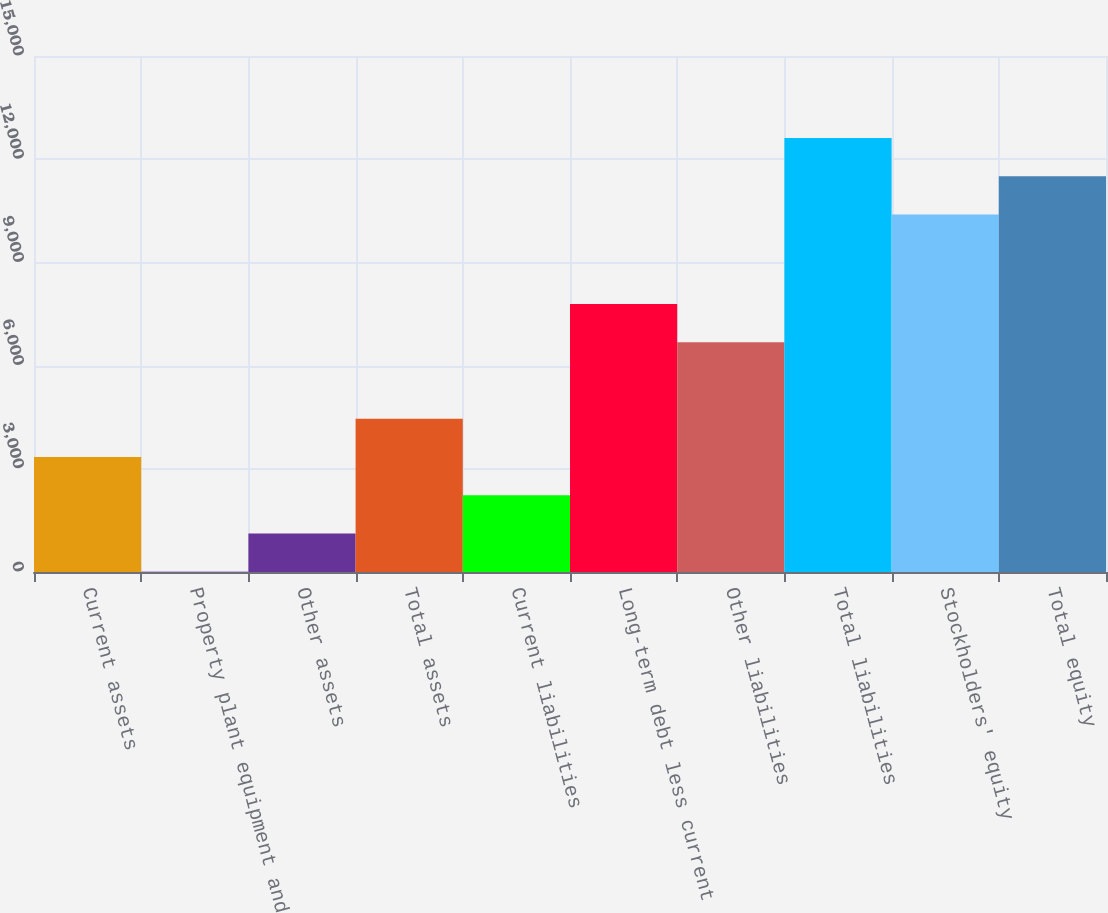Convert chart to OTSL. <chart><loc_0><loc_0><loc_500><loc_500><bar_chart><fcel>Current assets<fcel>Property plant equipment and<fcel>Other assets<fcel>Total assets<fcel>Current liabilities<fcel>Long-term debt less current<fcel>Other liabilities<fcel>Total liabilities<fcel>Stockholders' equity<fcel>Total equity<nl><fcel>3345.5<fcel>11<fcel>1122.5<fcel>4457<fcel>2234<fcel>7791.5<fcel>6680<fcel>12619<fcel>10396<fcel>11507.5<nl></chart> 